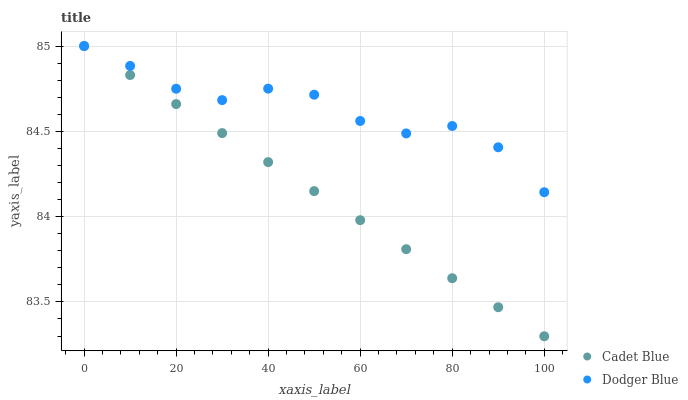Does Cadet Blue have the minimum area under the curve?
Answer yes or no. Yes. Does Dodger Blue have the maximum area under the curve?
Answer yes or no. Yes. Does Dodger Blue have the minimum area under the curve?
Answer yes or no. No. Is Cadet Blue the smoothest?
Answer yes or no. Yes. Is Dodger Blue the roughest?
Answer yes or no. Yes. Is Dodger Blue the smoothest?
Answer yes or no. No. Does Cadet Blue have the lowest value?
Answer yes or no. Yes. Does Dodger Blue have the lowest value?
Answer yes or no. No. Does Dodger Blue have the highest value?
Answer yes or no. Yes. Does Dodger Blue intersect Cadet Blue?
Answer yes or no. Yes. Is Dodger Blue less than Cadet Blue?
Answer yes or no. No. Is Dodger Blue greater than Cadet Blue?
Answer yes or no. No. 